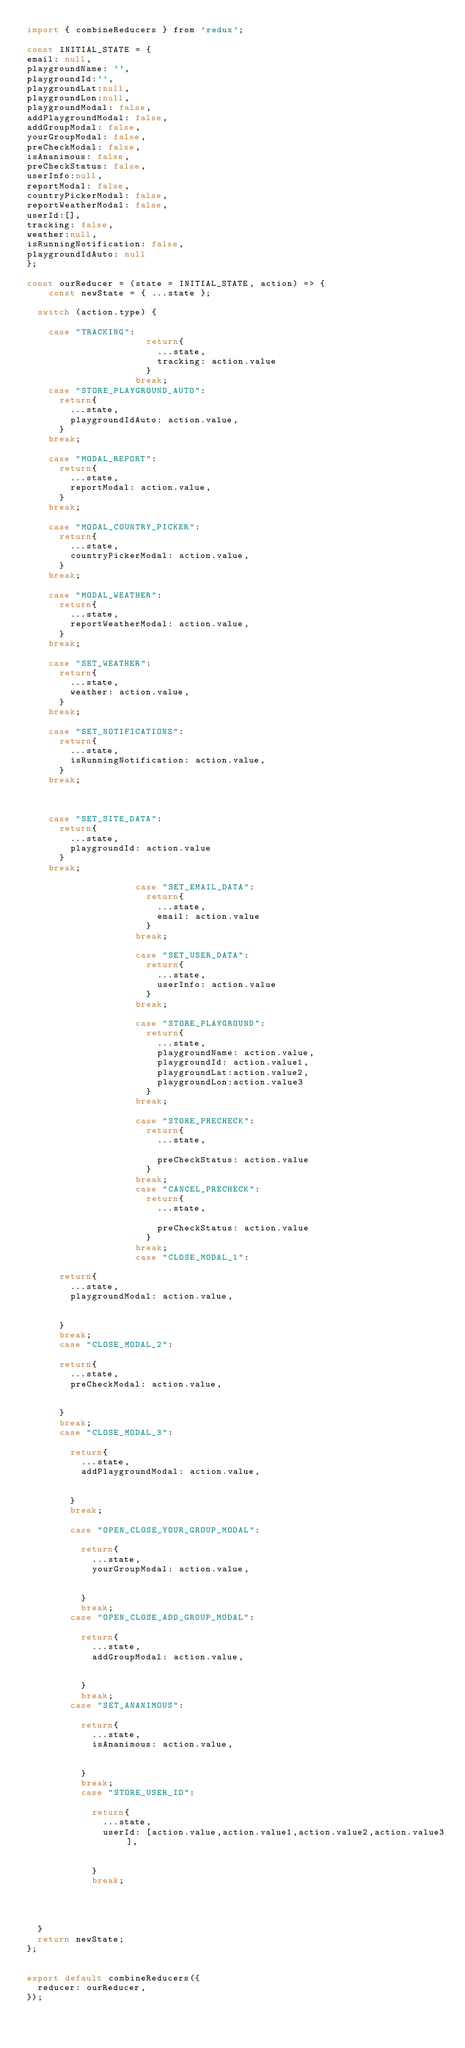Convert code to text. <code><loc_0><loc_0><loc_500><loc_500><_JavaScript_>import { combineReducers } from 'redux';

const INITIAL_STATE = {
email: null,
playgroundName: '',
playgroundId:'',
playgroundLat:null,
playgroundLon:null,
playgroundModal: false,
addPlaygroundModal: false,
addGroupModal: false,
yourGroupModal: false,
preCheckModal: false,
isAnanimous: false,
preCheckStatus: false,
userInfo:null,
reportModal: false,
countryPickerModal: false,
reportWeatherModal: false,
userId:[],
tracking: false,
weather:null,
isRunningNotification: false,
playgroundIdAuto: null
};

const ourReducer = (state = INITIAL_STATE, action) => {
    const newState = { ...state };

  switch (action.type) {

    case "TRACKING":
                      return{
                        ...state,
                        tracking: action.value
                      }
                    break;
    case "STORE_PLAYGROUND_AUTO":
      return{
        ...state,
        playgroundIdAuto: action.value,
      }
    break;
    
    case "MODAL_REPORT":
      return{
        ...state,
        reportModal: action.value,
      }
    break;

    case "MODAL_COUNTRY_PICKER":
      return{
        ...state,
        countryPickerModal: action.value,
      }
    break;

    case "MODAL_WEATHER":
      return{
        ...state,
        reportWeatherModal: action.value,
      }
    break;

    case "SET_WEATHER":
      return{
        ...state,
        weather: action.value,
      }
    break;

    case "SET_NOTIFICATIONS":
      return{
        ...state,
        isRunningNotification: action.value,
      }
    break;

    

    case "SET_SITE_DATA":
      return{
        ...state,
        playgroundId: action.value
      }
    break;

                    case "SET_EMAIL_DATA":
                      return{
                        ...state,
                        email: action.value
                      }
                    break;

                    case "SET_USER_DATA":
                      return{
                        ...state,
                        userInfo: action.value
                      }
                    break;

                    case "STORE_PLAYGROUND":
                      return{
                        ...state,
                        playgroundName: action.value,
                        playgroundId: action.value1,
                        playgroundLat:action.value2,
                        playgroundLon:action.value3
                      }
                    break;
                    
                    case "STORE_PRECHECK":
                      return{
                        ...state,
                        
                        preCheckStatus: action.value
                      }
                    break;
                    case "CANCEL_PRECHECK":
                      return{
                        ...state,
                        
                        preCheckStatus: action.value
                      }
                    break;
                    case "CLOSE_MODAL_1":
      
      return{
        ...state,
        playgroundModal: action.value,
        

      }
      break;
      case "CLOSE_MODAL_2":
      
      return{
        ...state,
        preCheckModal: action.value,
        

      }
      break;
      case "CLOSE_MODAL_3":
      
        return{
          ...state,
          addPlaygroundModal: action.value,
          
  
        }
        break;
        
        case "OPEN_CLOSE_YOUR_GROUP_MODAL":
      
          return{
            ...state,
            yourGroupModal: action.value,
            
    
          }
          break;
        case "OPEN_CLOSE_ADD_GROUP_MODAL":
      
          return{
            ...state,
            addGroupModal: action.value,
            
    
          }
          break;
        case "SET_ANANIMOUS":
      
          return{
            ...state,
            isAnanimous: action.value,
            
    
          }
          break;
          case "STORE_USER_ID":
      
            return{
              ...state,
              userId: [action.value,action.value1,action.value2,action.value3],
              
      
            }
            break;

         

  
  }
  return newState;
};


export default combineReducers({
  reducer: ourReducer,
});
</code> 